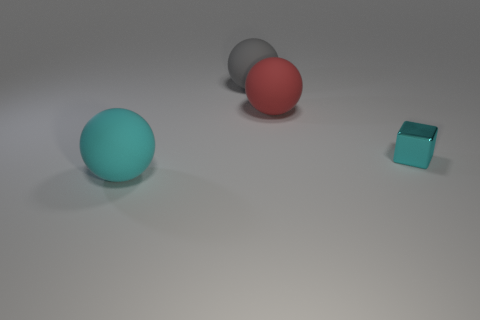There is a object that is left of the red matte sphere and behind the metallic object; what color is it?
Provide a succinct answer. Gray. What material is the red object that is the same shape as the cyan rubber thing?
Make the answer very short. Rubber. Is there anything else that is the same size as the gray matte object?
Your response must be concise. Yes. Are there more red rubber cylinders than big matte objects?
Your answer should be compact. No. What is the size of the matte thing that is behind the large cyan rubber object and in front of the gray ball?
Your response must be concise. Large. What shape is the cyan matte thing?
Your response must be concise. Sphere. What number of metallic objects are the same shape as the red matte object?
Provide a succinct answer. 0. Is the number of large spheres to the right of the tiny cyan metallic object less than the number of small cyan metallic objects that are in front of the red matte thing?
Offer a very short reply. Yes. There is a matte sphere in front of the big red ball; what number of large cyan objects are right of it?
Keep it short and to the point. 0. Are there any large spheres?
Your answer should be very brief. Yes. 